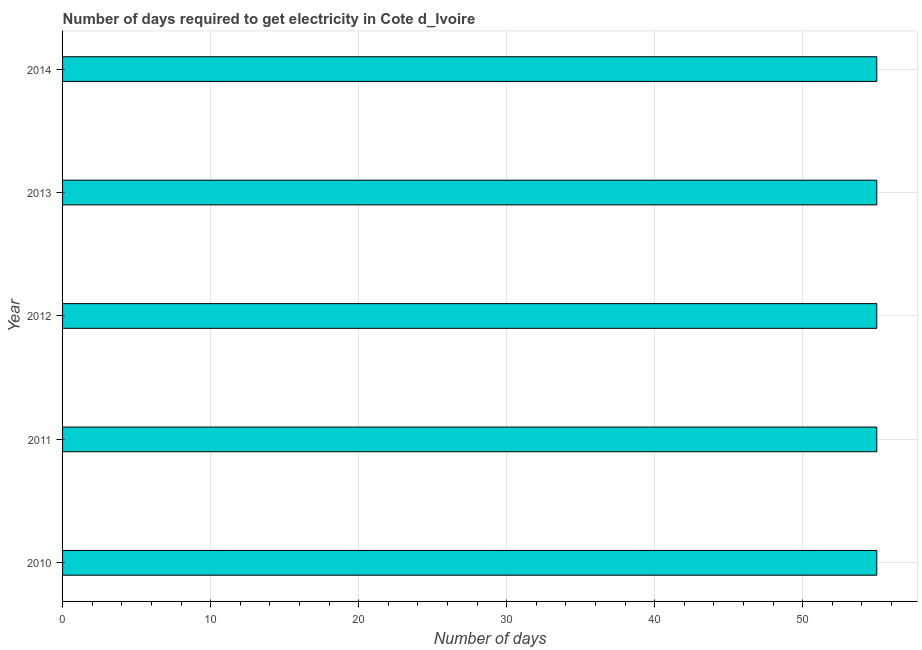Does the graph contain any zero values?
Provide a succinct answer. No. Does the graph contain grids?
Provide a short and direct response. Yes. What is the title of the graph?
Ensure brevity in your answer.  Number of days required to get electricity in Cote d_Ivoire. What is the label or title of the X-axis?
Make the answer very short. Number of days. What is the label or title of the Y-axis?
Your response must be concise. Year. Across all years, what is the maximum time to get electricity?
Your answer should be compact. 55. Across all years, what is the minimum time to get electricity?
Your answer should be very brief. 55. In which year was the time to get electricity maximum?
Your response must be concise. 2010. What is the sum of the time to get electricity?
Provide a short and direct response. 275. What is the median time to get electricity?
Ensure brevity in your answer.  55. In how many years, is the time to get electricity greater than 4 ?
Provide a short and direct response. 5. What is the ratio of the time to get electricity in 2010 to that in 2011?
Your answer should be very brief. 1. Is the time to get electricity in 2010 less than that in 2014?
Provide a succinct answer. No. Is the difference between the time to get electricity in 2011 and 2012 greater than the difference between any two years?
Keep it short and to the point. Yes. What is the difference between the highest and the second highest time to get electricity?
Your answer should be compact. 0. Is the sum of the time to get electricity in 2011 and 2012 greater than the maximum time to get electricity across all years?
Make the answer very short. Yes. What is the difference between the highest and the lowest time to get electricity?
Provide a succinct answer. 0. Are all the bars in the graph horizontal?
Make the answer very short. Yes. How many years are there in the graph?
Give a very brief answer. 5. What is the difference between two consecutive major ticks on the X-axis?
Ensure brevity in your answer.  10. Are the values on the major ticks of X-axis written in scientific E-notation?
Your response must be concise. No. What is the Number of days in 2011?
Provide a succinct answer. 55. What is the Number of days in 2012?
Keep it short and to the point. 55. What is the difference between the Number of days in 2010 and 2011?
Your answer should be compact. 0. What is the difference between the Number of days in 2010 and 2012?
Offer a terse response. 0. What is the difference between the Number of days in 2011 and 2012?
Your answer should be compact. 0. What is the ratio of the Number of days in 2010 to that in 2013?
Keep it short and to the point. 1. What is the ratio of the Number of days in 2010 to that in 2014?
Keep it short and to the point. 1. What is the ratio of the Number of days in 2011 to that in 2012?
Your response must be concise. 1. What is the ratio of the Number of days in 2012 to that in 2014?
Provide a succinct answer. 1. What is the ratio of the Number of days in 2013 to that in 2014?
Make the answer very short. 1. 